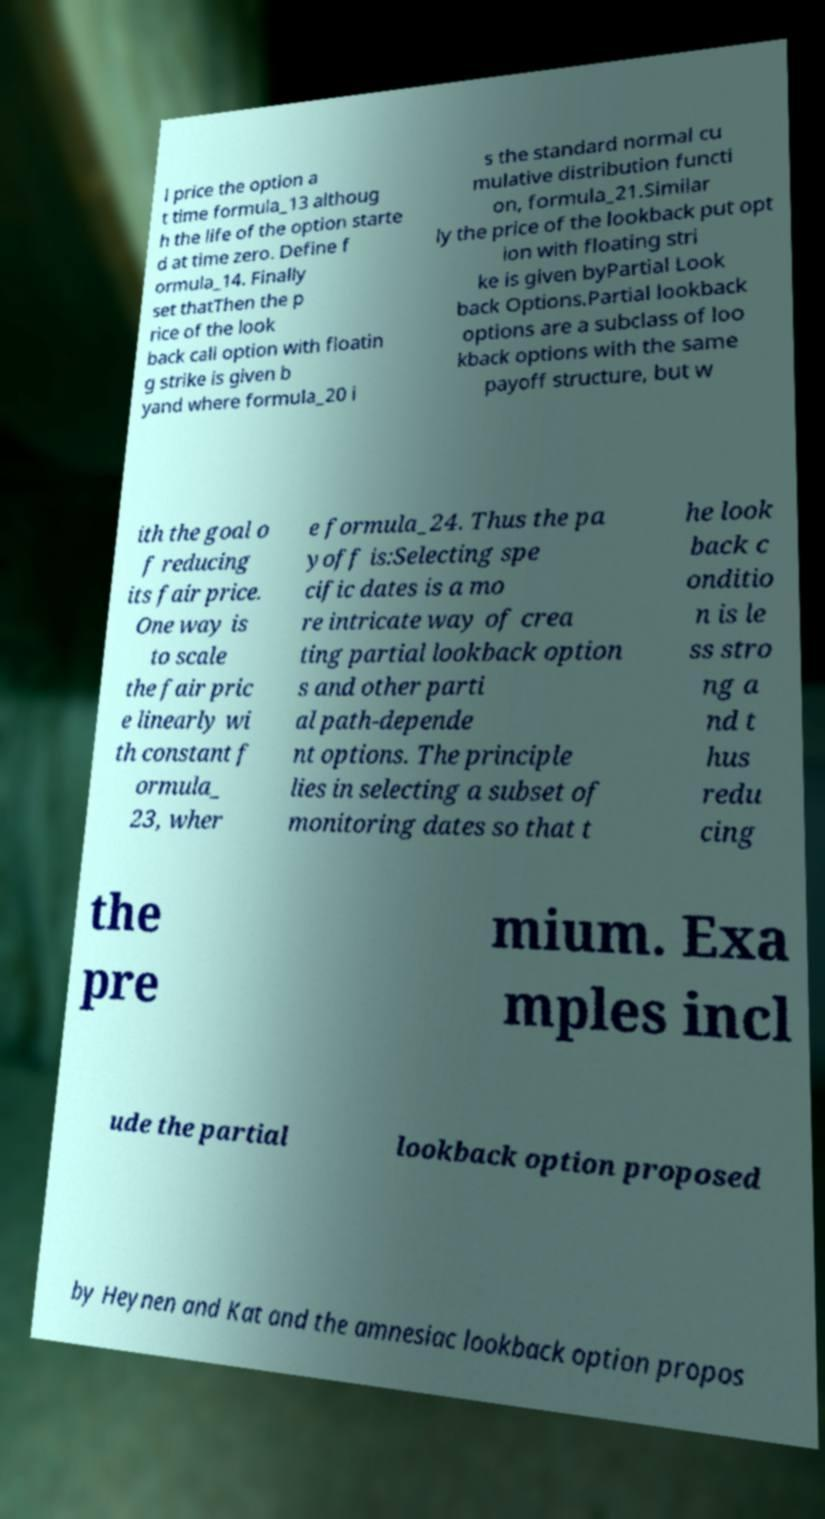Could you extract and type out the text from this image? l price the option a t time formula_13 althoug h the life of the option starte d at time zero. Define f ormula_14. Finally set thatThen the p rice of the look back call option with floatin g strike is given b yand where formula_20 i s the standard normal cu mulative distribution functi on, formula_21.Similar ly the price of the lookback put opt ion with floating stri ke is given byPartial Look back Options.Partial lookback options are a subclass of loo kback options with the same payoff structure, but w ith the goal o f reducing its fair price. One way is to scale the fair pric e linearly wi th constant f ormula_ 23, wher e formula_24. Thus the pa yoff is:Selecting spe cific dates is a mo re intricate way of crea ting partial lookback option s and other parti al path-depende nt options. The principle lies in selecting a subset of monitoring dates so that t he look back c onditio n is le ss stro ng a nd t hus redu cing the pre mium. Exa mples incl ude the partial lookback option proposed by Heynen and Kat and the amnesiac lookback option propos 